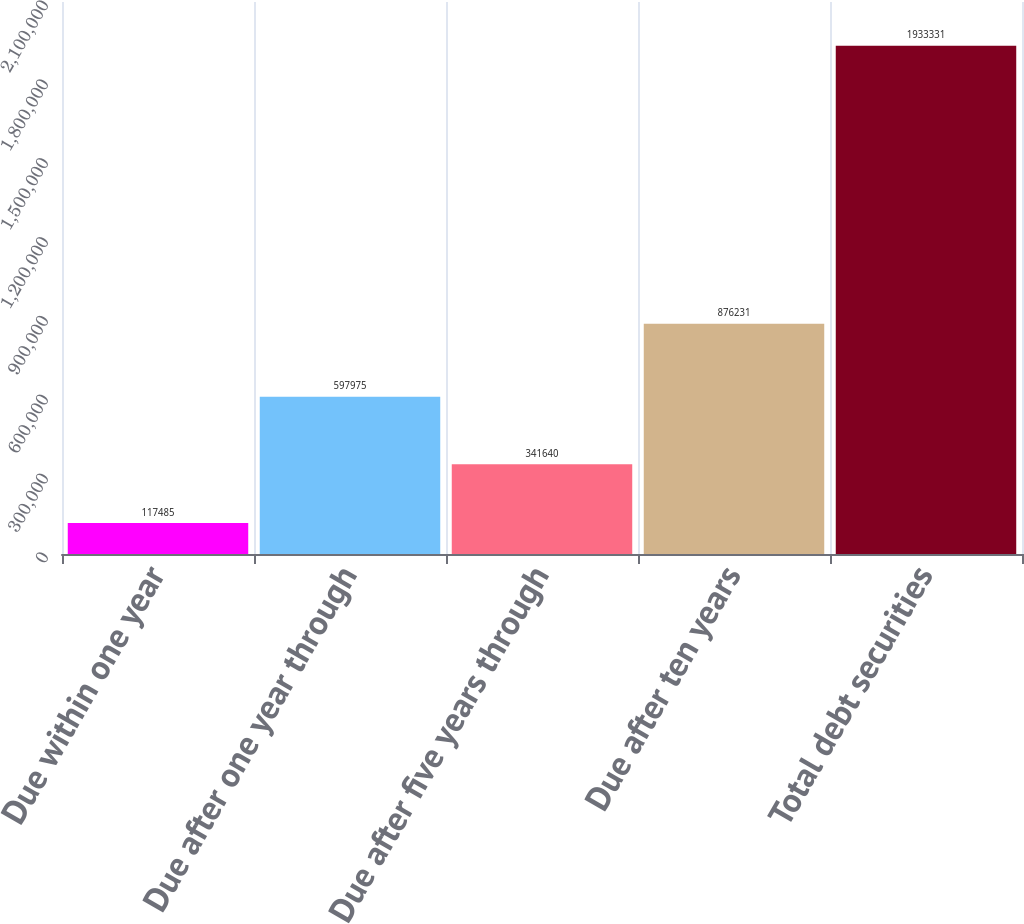<chart> <loc_0><loc_0><loc_500><loc_500><bar_chart><fcel>Due within one year<fcel>Due after one year through<fcel>Due after five years through<fcel>Due after ten years<fcel>Total debt securities<nl><fcel>117485<fcel>597975<fcel>341640<fcel>876231<fcel>1.93333e+06<nl></chart> 